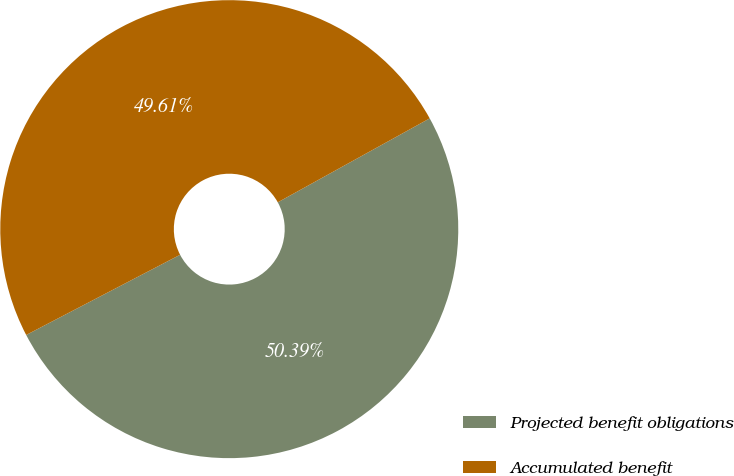Convert chart to OTSL. <chart><loc_0><loc_0><loc_500><loc_500><pie_chart><fcel>Projected benefit obligations<fcel>Accumulated benefit<nl><fcel>50.39%<fcel>49.61%<nl></chart> 